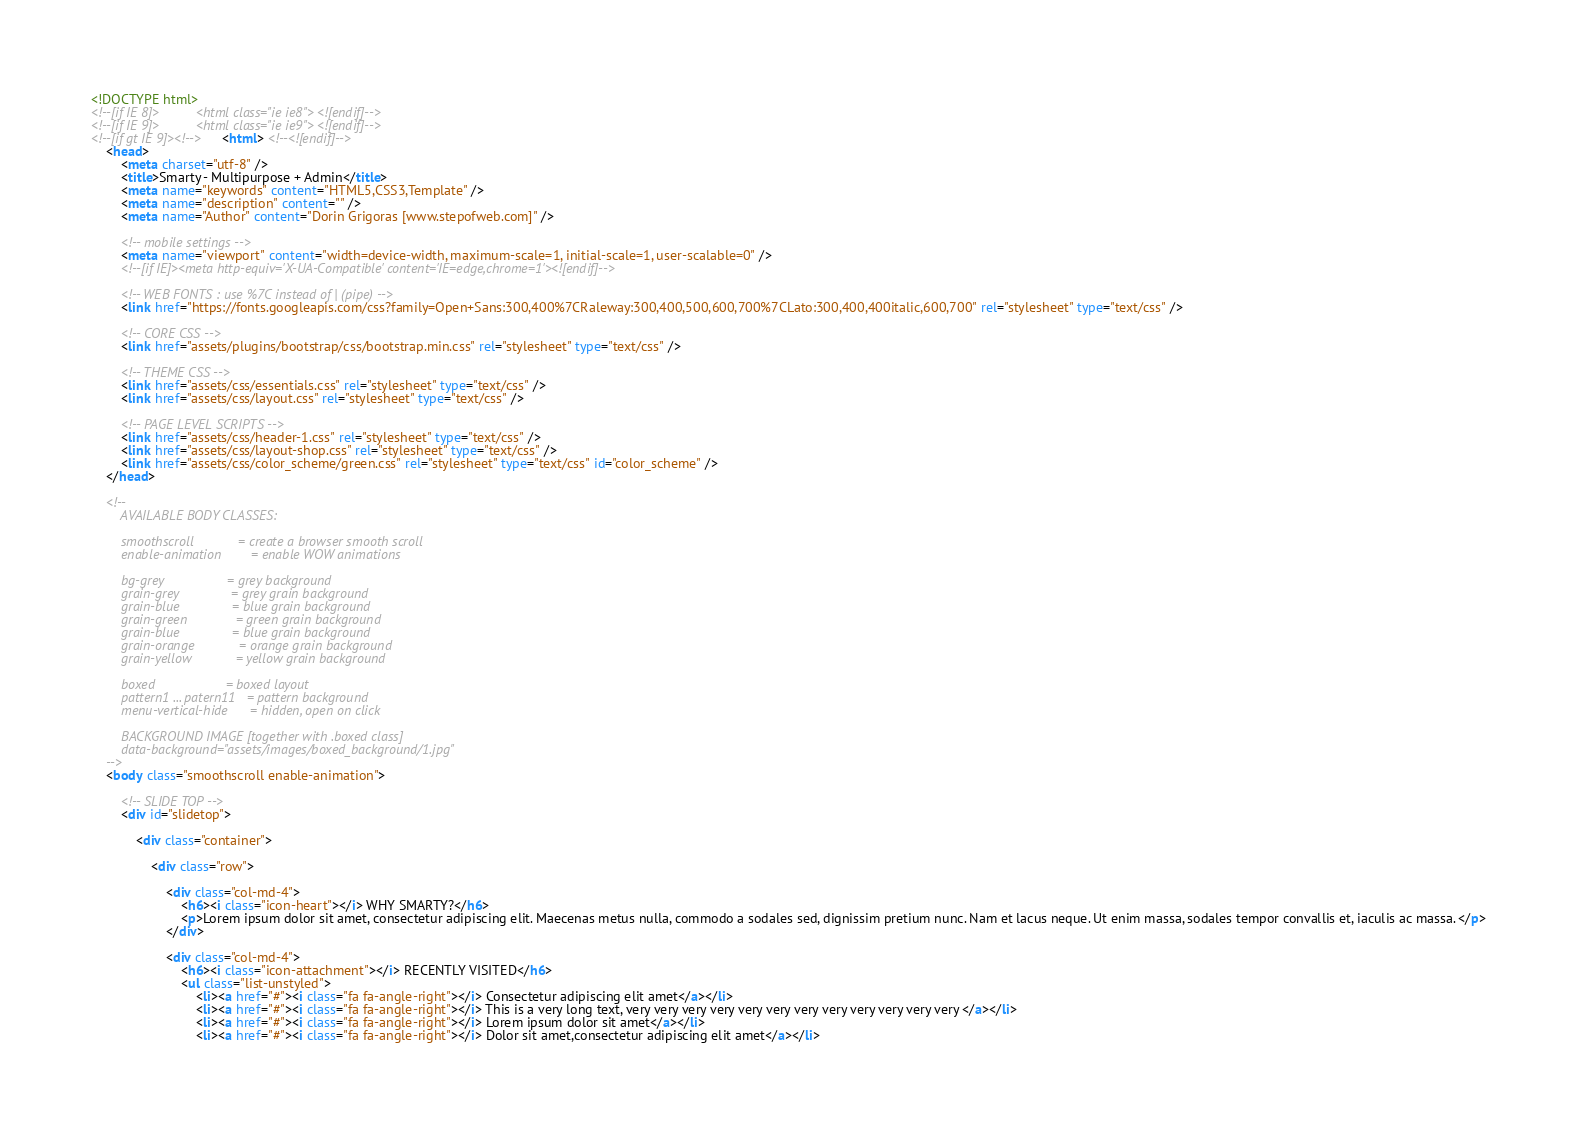Convert code to text. <code><loc_0><loc_0><loc_500><loc_500><_HTML_><!DOCTYPE html>
<!--[if IE 8]>			<html class="ie ie8"> <![endif]-->
<!--[if IE 9]>			<html class="ie ie9"> <![endif]-->
<!--[if gt IE 9]><!-->	<html> <!--<![endif]-->
	<head>
		<meta charset="utf-8" />
		<title>Smarty - Multipurpose + Admin</title>
		<meta name="keywords" content="HTML5,CSS3,Template" />
		<meta name="description" content="" />
		<meta name="Author" content="Dorin Grigoras [www.stepofweb.com]" />

		<!-- mobile settings -->
		<meta name="viewport" content="width=device-width, maximum-scale=1, initial-scale=1, user-scalable=0" />
		<!--[if IE]><meta http-equiv='X-UA-Compatible' content='IE=edge,chrome=1'><![endif]-->

		<!-- WEB FONTS : use %7C instead of | (pipe) -->
		<link href="https://fonts.googleapis.com/css?family=Open+Sans:300,400%7CRaleway:300,400,500,600,700%7CLato:300,400,400italic,600,700" rel="stylesheet" type="text/css" />

		<!-- CORE CSS -->
		<link href="assets/plugins/bootstrap/css/bootstrap.min.css" rel="stylesheet" type="text/css" />
		
		<!-- THEME CSS -->
		<link href="assets/css/essentials.css" rel="stylesheet" type="text/css" />
		<link href="assets/css/layout.css" rel="stylesheet" type="text/css" />

		<!-- PAGE LEVEL SCRIPTS -->
		<link href="assets/css/header-1.css" rel="stylesheet" type="text/css" />
		<link href="assets/css/layout-shop.css" rel="stylesheet" type="text/css" />
		<link href="assets/css/color_scheme/green.css" rel="stylesheet" type="text/css" id="color_scheme" />
	</head>

	<!--
		AVAILABLE BODY CLASSES:
		
		smoothscroll 			= create a browser smooth scroll
		enable-animation		= enable WOW animations

		bg-grey					= grey background
		grain-grey				= grey grain background
		grain-blue				= blue grain background
		grain-green				= green grain background
		grain-blue				= blue grain background
		grain-orange			= orange grain background
		grain-yellow			= yellow grain background
		
		boxed 					= boxed layout
		pattern1 ... patern11	= pattern background
		menu-vertical-hide		= hidden, open on click
		
		BACKGROUND IMAGE [together with .boxed class]
		data-background="assets/images/boxed_background/1.jpg"
	-->
	<body class="smoothscroll enable-animation">

		<!-- SLIDE TOP -->
		<div id="slidetop">

			<div class="container">
				
				<div class="row">

					<div class="col-md-4">
						<h6><i class="icon-heart"></i> WHY SMARTY?</h6>
						<p>Lorem ipsum dolor sit amet, consectetur adipiscing elit. Maecenas metus nulla, commodo a sodales sed, dignissim pretium nunc. Nam et lacus neque. Ut enim massa, sodales tempor convallis et, iaculis ac massa. </p>
					</div>

					<div class="col-md-4">
						<h6><i class="icon-attachment"></i> RECENTLY VISITED</h6>
						<ul class="list-unstyled">
							<li><a href="#"><i class="fa fa-angle-right"></i> Consectetur adipiscing elit amet</a></li>
							<li><a href="#"><i class="fa fa-angle-right"></i> This is a very long text, very very very very very very very very very very very very </a></li>
							<li><a href="#"><i class="fa fa-angle-right"></i> Lorem ipsum dolor sit amet</a></li>
							<li><a href="#"><i class="fa fa-angle-right"></i> Dolor sit amet,consectetur adipiscing elit amet</a></li></code> 